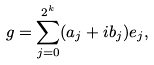<formula> <loc_0><loc_0><loc_500><loc_500>g = \sum _ { j = 0 } ^ { 2 ^ { k } } ( a _ { j } + i b _ { j } ) e _ { j } ,</formula> 